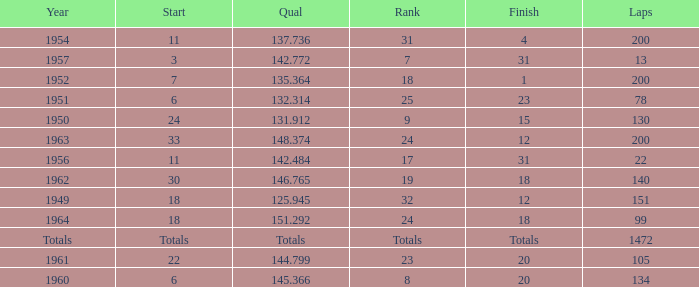Name the rank with finish of 12 and year of 1963 24.0. 